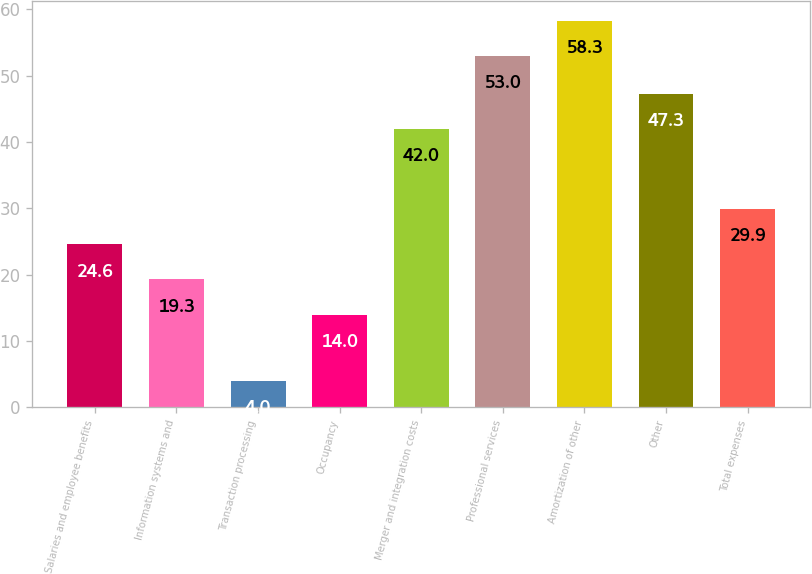<chart> <loc_0><loc_0><loc_500><loc_500><bar_chart><fcel>Salaries and employee benefits<fcel>Information systems and<fcel>Transaction processing<fcel>Occupancy<fcel>Merger and integration costs<fcel>Professional services<fcel>Amortization of other<fcel>Other<fcel>Total expenses<nl><fcel>24.6<fcel>19.3<fcel>4<fcel>14<fcel>42<fcel>53<fcel>58.3<fcel>47.3<fcel>29.9<nl></chart> 